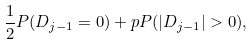Convert formula to latex. <formula><loc_0><loc_0><loc_500><loc_500>\frac { 1 } { 2 } P ( D _ { j - 1 } = 0 ) + p P ( | D _ { j - 1 } | > 0 ) ,</formula> 